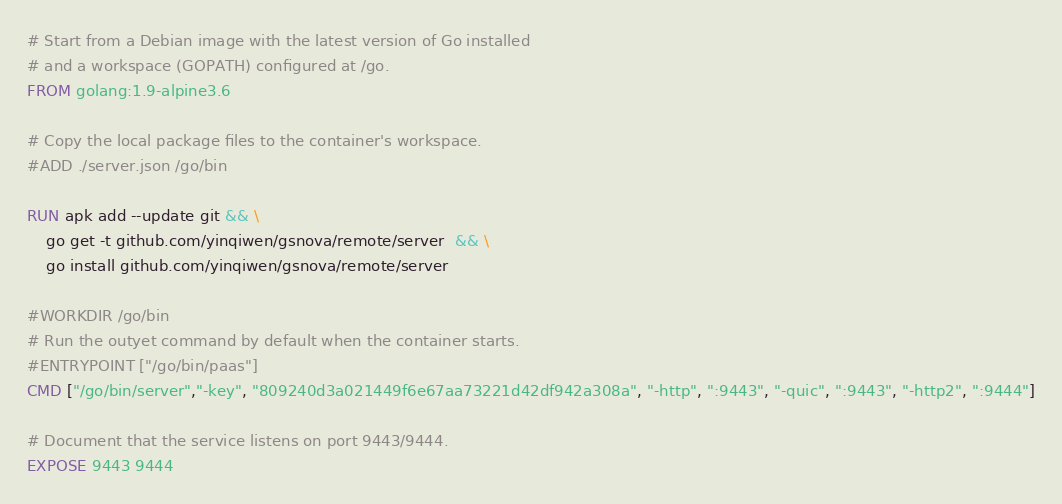Convert code to text. <code><loc_0><loc_0><loc_500><loc_500><_Dockerfile_># Start from a Debian image with the latest version of Go installed
# and a workspace (GOPATH) configured at /go.
FROM golang:1.9-alpine3.6

# Copy the local package files to the container's workspace.
#ADD ./server.json /go/bin

RUN apk add --update git && \
    go get -t github.com/yinqiwen/gsnova/remote/server  && \
    go install github.com/yinqiwen/gsnova/remote/server 

#WORKDIR /go/bin
# Run the outyet command by default when the container starts.
#ENTRYPOINT ["/go/bin/paas"]
CMD ["/go/bin/server","-key", "809240d3a021449f6e67aa73221d42df942a308a", "-http", ":9443", "-quic", ":9443", "-http2", ":9444"]

# Document that the service listens on port 9443/9444.
EXPOSE 9443 9444</code> 